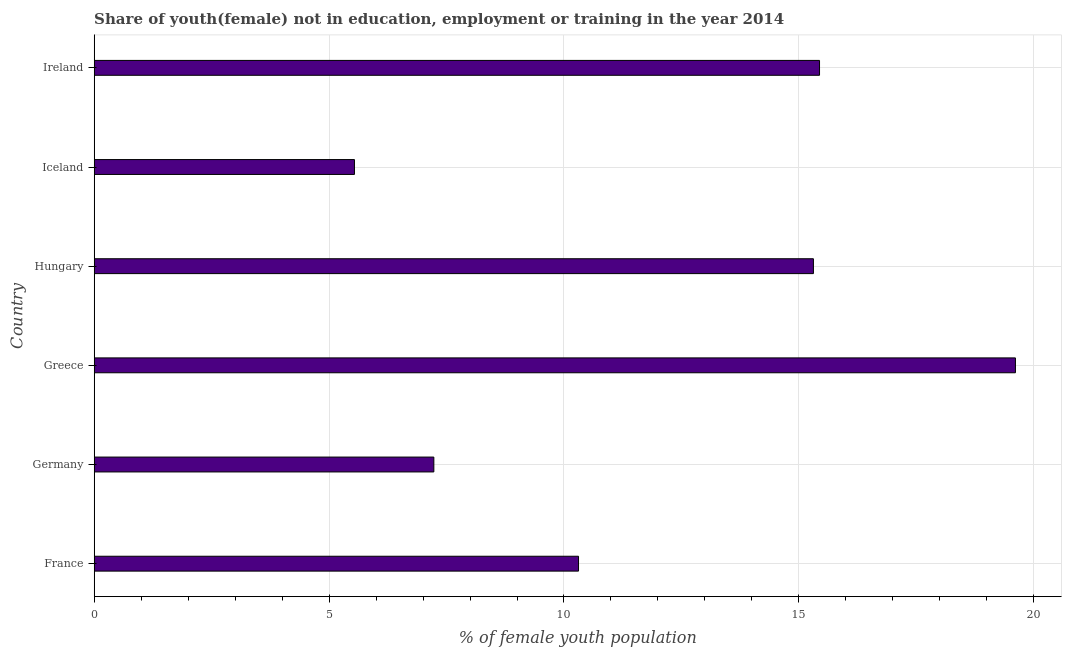Does the graph contain any zero values?
Keep it short and to the point. No. Does the graph contain grids?
Provide a short and direct response. Yes. What is the title of the graph?
Your answer should be very brief. Share of youth(female) not in education, employment or training in the year 2014. What is the label or title of the X-axis?
Keep it short and to the point. % of female youth population. What is the label or title of the Y-axis?
Make the answer very short. Country. What is the unemployed female youth population in Hungary?
Your answer should be compact. 15.31. Across all countries, what is the maximum unemployed female youth population?
Offer a terse response. 19.61. Across all countries, what is the minimum unemployed female youth population?
Your response must be concise. 5.54. In which country was the unemployed female youth population minimum?
Make the answer very short. Iceland. What is the sum of the unemployed female youth population?
Your response must be concise. 73.44. What is the difference between the unemployed female youth population in Greece and Ireland?
Provide a succinct answer. 4.17. What is the average unemployed female youth population per country?
Give a very brief answer. 12.24. What is the median unemployed female youth population?
Keep it short and to the point. 12.81. In how many countries, is the unemployed female youth population greater than 2 %?
Offer a very short reply. 6. What is the ratio of the unemployed female youth population in Germany to that in Iceland?
Your answer should be compact. 1.3. Is the unemployed female youth population in Germany less than that in Iceland?
Your answer should be very brief. No. Is the difference between the unemployed female youth population in Germany and Greece greater than the difference between any two countries?
Make the answer very short. No. What is the difference between the highest and the second highest unemployed female youth population?
Your response must be concise. 4.17. Is the sum of the unemployed female youth population in Hungary and Iceland greater than the maximum unemployed female youth population across all countries?
Ensure brevity in your answer.  Yes. What is the difference between the highest and the lowest unemployed female youth population?
Ensure brevity in your answer.  14.07. How many bars are there?
Provide a succinct answer. 6. How many countries are there in the graph?
Make the answer very short. 6. What is the difference between two consecutive major ticks on the X-axis?
Your answer should be very brief. 5. Are the values on the major ticks of X-axis written in scientific E-notation?
Ensure brevity in your answer.  No. What is the % of female youth population of France?
Provide a succinct answer. 10.31. What is the % of female youth population of Germany?
Ensure brevity in your answer.  7.23. What is the % of female youth population of Greece?
Your answer should be very brief. 19.61. What is the % of female youth population in Hungary?
Offer a terse response. 15.31. What is the % of female youth population of Iceland?
Offer a terse response. 5.54. What is the % of female youth population of Ireland?
Offer a terse response. 15.44. What is the difference between the % of female youth population in France and Germany?
Give a very brief answer. 3.08. What is the difference between the % of female youth population in France and Iceland?
Offer a very short reply. 4.77. What is the difference between the % of female youth population in France and Ireland?
Give a very brief answer. -5.13. What is the difference between the % of female youth population in Germany and Greece?
Provide a succinct answer. -12.38. What is the difference between the % of female youth population in Germany and Hungary?
Provide a succinct answer. -8.08. What is the difference between the % of female youth population in Germany and Iceland?
Offer a terse response. 1.69. What is the difference between the % of female youth population in Germany and Ireland?
Make the answer very short. -8.21. What is the difference between the % of female youth population in Greece and Hungary?
Give a very brief answer. 4.3. What is the difference between the % of female youth population in Greece and Iceland?
Provide a short and direct response. 14.07. What is the difference between the % of female youth population in Greece and Ireland?
Provide a succinct answer. 4.17. What is the difference between the % of female youth population in Hungary and Iceland?
Your response must be concise. 9.77. What is the difference between the % of female youth population in Hungary and Ireland?
Your response must be concise. -0.13. What is the difference between the % of female youth population in Iceland and Ireland?
Provide a succinct answer. -9.9. What is the ratio of the % of female youth population in France to that in Germany?
Your response must be concise. 1.43. What is the ratio of the % of female youth population in France to that in Greece?
Your answer should be very brief. 0.53. What is the ratio of the % of female youth population in France to that in Hungary?
Provide a short and direct response. 0.67. What is the ratio of the % of female youth population in France to that in Iceland?
Give a very brief answer. 1.86. What is the ratio of the % of female youth population in France to that in Ireland?
Offer a very short reply. 0.67. What is the ratio of the % of female youth population in Germany to that in Greece?
Keep it short and to the point. 0.37. What is the ratio of the % of female youth population in Germany to that in Hungary?
Provide a short and direct response. 0.47. What is the ratio of the % of female youth population in Germany to that in Iceland?
Your answer should be very brief. 1.3. What is the ratio of the % of female youth population in Germany to that in Ireland?
Keep it short and to the point. 0.47. What is the ratio of the % of female youth population in Greece to that in Hungary?
Offer a very short reply. 1.28. What is the ratio of the % of female youth population in Greece to that in Iceland?
Ensure brevity in your answer.  3.54. What is the ratio of the % of female youth population in Greece to that in Ireland?
Provide a succinct answer. 1.27. What is the ratio of the % of female youth population in Hungary to that in Iceland?
Offer a terse response. 2.76. What is the ratio of the % of female youth population in Iceland to that in Ireland?
Your answer should be very brief. 0.36. 